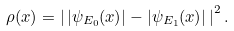<formula> <loc_0><loc_0><loc_500><loc_500>\rho ( x ) = \left | \, | \psi _ { E _ { 0 } } ( x ) | - | \psi _ { E _ { 1 } } ( x ) | \, \right | ^ { 2 } .</formula> 